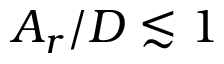Convert formula to latex. <formula><loc_0><loc_0><loc_500><loc_500>A _ { r } / D \lesssim 1</formula> 